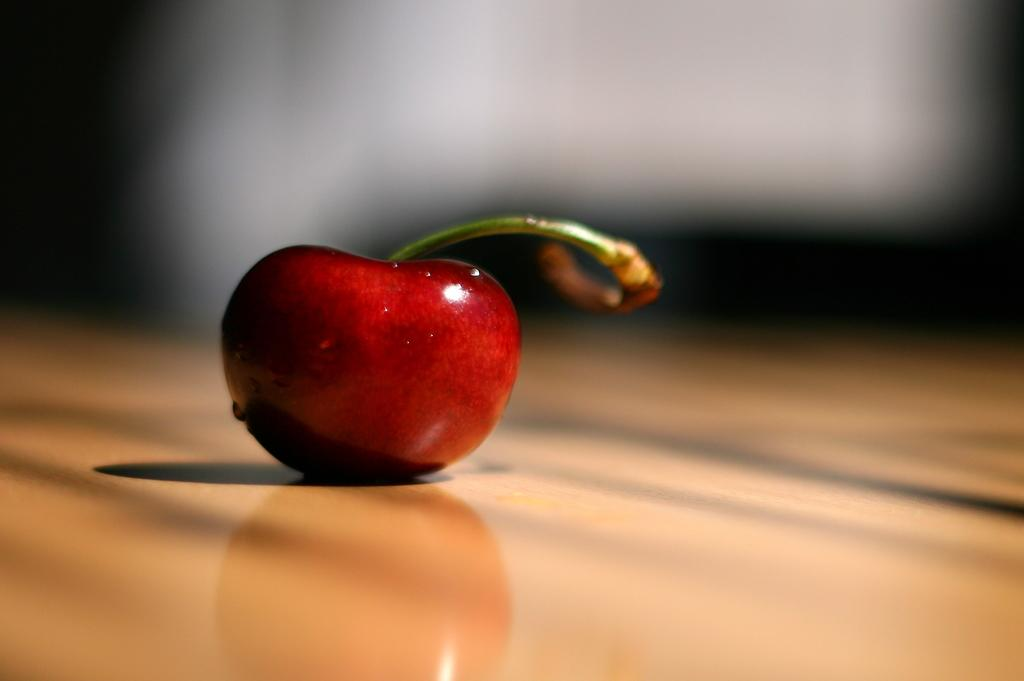What type of food is present in the image? There is a fruit in the image. What color is the fruit in the image? The fruit is red in color. Is the fruit wearing a cap in the image? No, the fruit is not wearing a cap in the image. Is there a birthday celebration happening in the image? No, there is no indication of a birthday celebration in the image. 